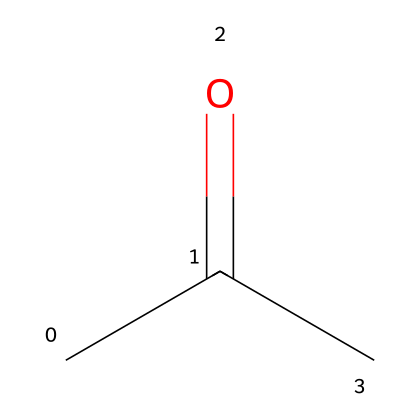What is the name of this compound? The SMILES representation, CC(=O)C, corresponds to acetone. Acetone is a common name for this compound, which is known as propan-2-one in IUPAC nomenclature.
Answer: acetone How many carbon atoms are in acetone? The SMILES code CC(=O)C shows that there are three carbon atoms represented by the "C" characters. Counting them gives the total of three.
Answer: three What type of functional group does acetone contain? The structure indicates the presence of a carbonyl group (C=O) attached to a carbon chain. This functional group is characteristic of ketones, which includes acetone.
Answer: carbonyl How many hydrogen atoms are in acetone? In the SMILES representation CC(=O)C, the arrangement indicates that each terminal carbon is bonded to three hydrogen atoms and the carbon in the middle is bonded to one. Therefore, the total is six hydrogen atoms.
Answer: six Is acetone a saturated or unsaturated compound? The structure CC(=O)C depicts a carbon chain with no double or triple bonds except for the carbonyl functional group, classifying it as a saturated compound since there are no additional double bonds outside the carbonyl.
Answer: saturated What is the molecular formula of acetone? By adding the counts of carbon (3), hydrogen (6), and oxygen (1) based on the structure provided, we derive the molecular formula C3H6O for acetone.
Answer: C3H6O 